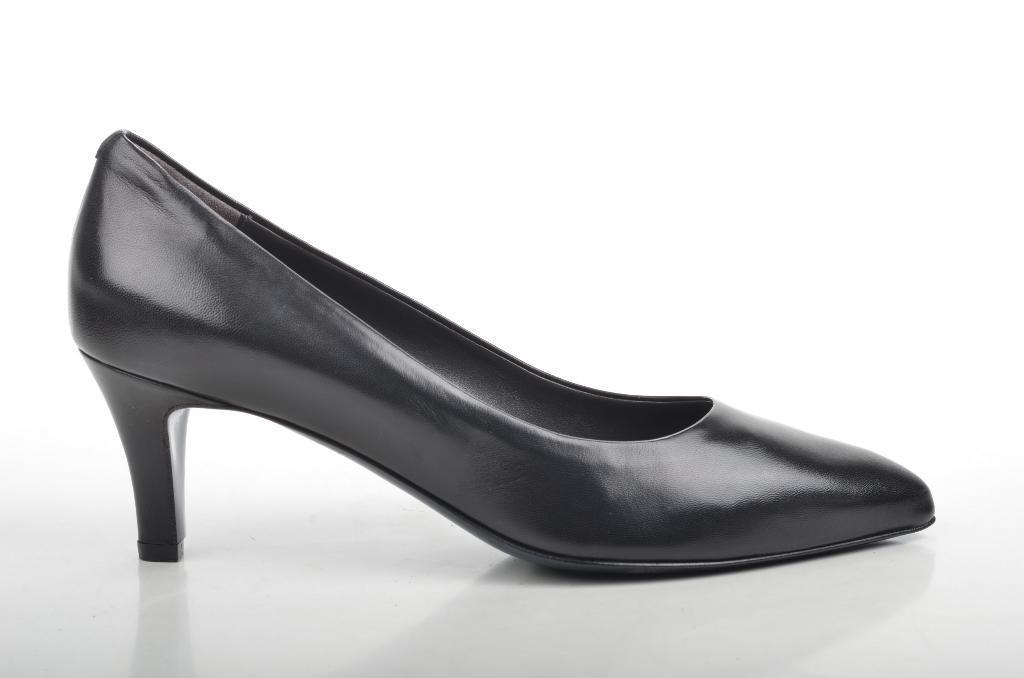Could you give a brief overview of what you see in this image? In this image there is a black color shoe heel on the object. 